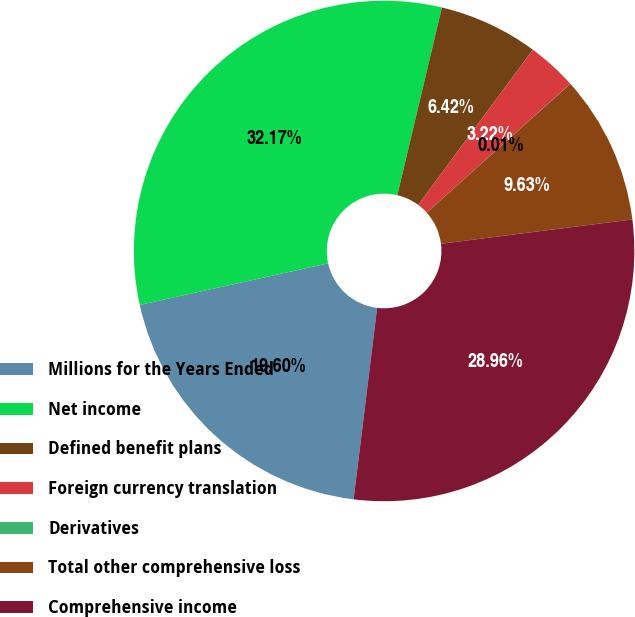Convert chart. <chart><loc_0><loc_0><loc_500><loc_500><pie_chart><fcel>Millions for the Years Ended<fcel>Net income<fcel>Defined benefit plans<fcel>Foreign currency translation<fcel>Derivatives<fcel>Total other comprehensive loss<fcel>Comprehensive income<nl><fcel>19.6%<fcel>32.17%<fcel>6.42%<fcel>3.22%<fcel>0.01%<fcel>9.63%<fcel>28.96%<nl></chart> 